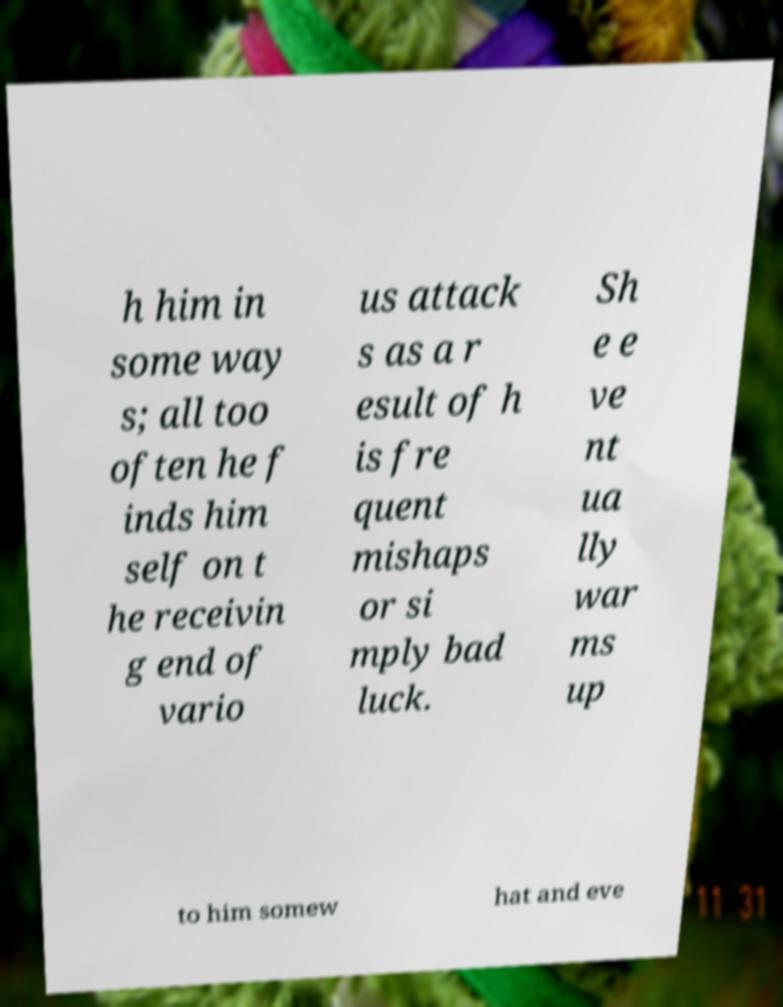Could you extract and type out the text from this image? h him in some way s; all too often he f inds him self on t he receivin g end of vario us attack s as a r esult of h is fre quent mishaps or si mply bad luck. Sh e e ve nt ua lly war ms up to him somew hat and eve 